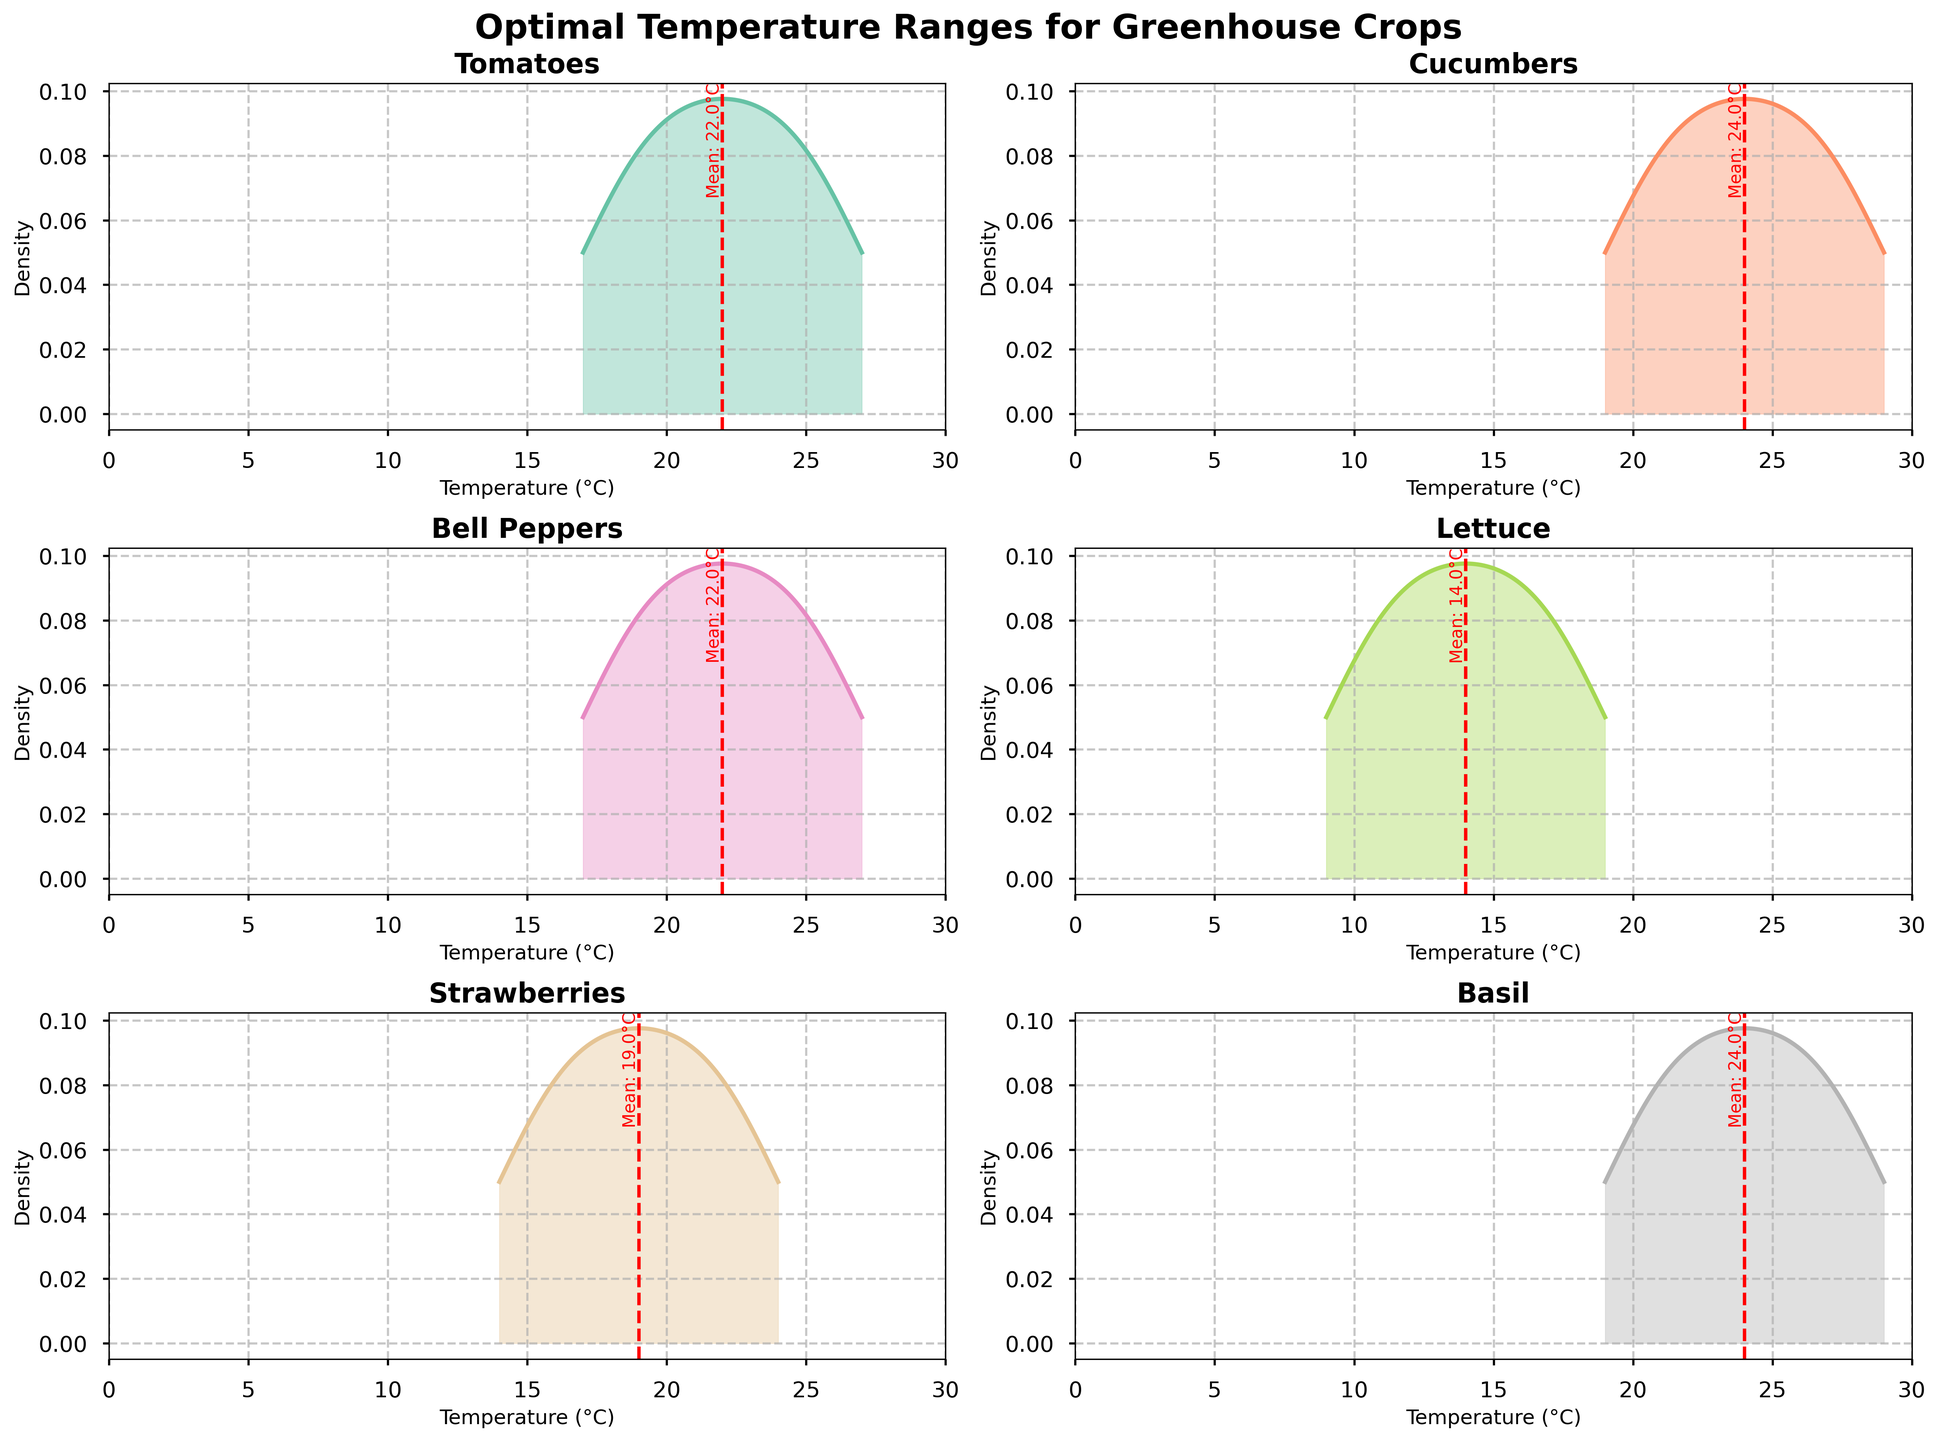What is the title of the figure? The title is typically located at the top center of the figure in a large, bold font.
Answer: Optimal Temperature Ranges for Greenhouse Crops What does the red dashed line represent in each subplot? The red dashed line is a reference line that appears in each subplot, indicating the mean temperature for that specific crop by aligning vertically with its value on the x-axis.
Answer: Mean temperature Which crop has the highest mean temperature? Locate the red dashed line in each subplot and find the one that is furthest to the right, as the x-axis represents temperature values.
Answer: Basil What is the approximate mean temperature for Strawberries? Reference the red dashed line in the Strawberries subplot and read the corresponding temperature value from the x-axis.
Answer: 19°C Which crop has the lowest optimal temperature range? Compare the density plots of all crops and identify which one has its peak closer to the lower end of the x-axis (temperature range).
Answer: Lettuce Between Lettuce and Bell Peppers, which has a broader optimal temperature range? Compare the horizontal spread of the density plots for Lettuce and Bell Peppers; broader spread indicates a wider temperature range.
Answer: Bell Peppers How many subplots are there in the figure? Count the individual plots, including rows and columns, adjusting for any empty spaces due to an odd number of crops.
Answer: 6 What is the x-axis label in each subplot? Inspect any of the subplots to see the label displayed along the horizontal axis.
Answer: Temperature (°C) For which crop does the optimal temperature distribution have the highest peak? Find the subplot with the highest density peak (y-axis value) for its temperature range (x-axis).
Answer: Strawberries Which two crops have overlapping optimal temperature ranges between 20°C and 24°C? Observe the subplots and identify which crops have density curves within the 20°C to 24°C range on the x-axis.
Answer: Tomatoes and Cucumbers 